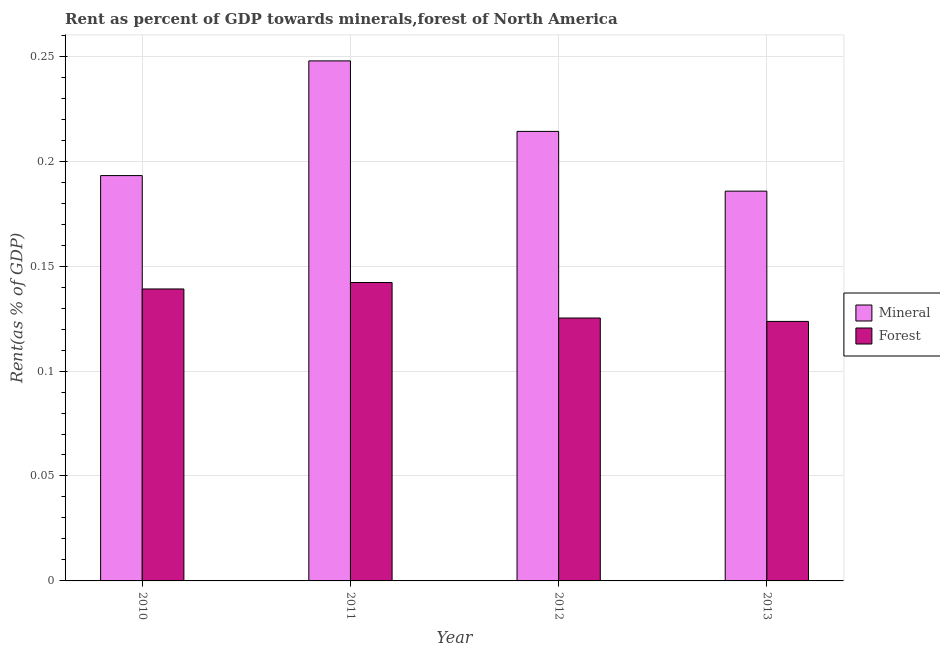How many different coloured bars are there?
Your answer should be compact. 2. How many bars are there on the 1st tick from the left?
Provide a succinct answer. 2. What is the label of the 2nd group of bars from the left?
Ensure brevity in your answer.  2011. In how many cases, is the number of bars for a given year not equal to the number of legend labels?
Offer a terse response. 0. What is the forest rent in 2012?
Your response must be concise. 0.13. Across all years, what is the maximum forest rent?
Keep it short and to the point. 0.14. Across all years, what is the minimum mineral rent?
Offer a very short reply. 0.19. In which year was the mineral rent maximum?
Offer a terse response. 2011. What is the total forest rent in the graph?
Offer a terse response. 0.53. What is the difference between the forest rent in 2011 and that in 2012?
Provide a short and direct response. 0.02. What is the difference between the forest rent in 2012 and the mineral rent in 2010?
Your response must be concise. -0.01. What is the average forest rent per year?
Offer a very short reply. 0.13. In the year 2010, what is the difference between the mineral rent and forest rent?
Your answer should be compact. 0. What is the ratio of the forest rent in 2010 to that in 2012?
Provide a succinct answer. 1.11. Is the difference between the mineral rent in 2010 and 2012 greater than the difference between the forest rent in 2010 and 2012?
Make the answer very short. No. What is the difference between the highest and the second highest mineral rent?
Your answer should be very brief. 0.03. What is the difference between the highest and the lowest mineral rent?
Offer a very short reply. 0.06. Is the sum of the forest rent in 2011 and 2013 greater than the maximum mineral rent across all years?
Provide a short and direct response. Yes. What does the 2nd bar from the left in 2010 represents?
Your answer should be very brief. Forest. What does the 1st bar from the right in 2013 represents?
Your answer should be compact. Forest. Are all the bars in the graph horizontal?
Ensure brevity in your answer.  No. What is the difference between two consecutive major ticks on the Y-axis?
Your answer should be very brief. 0.05. Are the values on the major ticks of Y-axis written in scientific E-notation?
Ensure brevity in your answer.  No. Where does the legend appear in the graph?
Provide a short and direct response. Center right. How many legend labels are there?
Offer a terse response. 2. What is the title of the graph?
Your answer should be compact. Rent as percent of GDP towards minerals,forest of North America. What is the label or title of the Y-axis?
Make the answer very short. Rent(as % of GDP). What is the Rent(as % of GDP) of Mineral in 2010?
Offer a terse response. 0.19. What is the Rent(as % of GDP) of Forest in 2010?
Provide a short and direct response. 0.14. What is the Rent(as % of GDP) in Mineral in 2011?
Your response must be concise. 0.25. What is the Rent(as % of GDP) of Forest in 2011?
Offer a terse response. 0.14. What is the Rent(as % of GDP) in Mineral in 2012?
Give a very brief answer. 0.21. What is the Rent(as % of GDP) in Forest in 2012?
Offer a terse response. 0.13. What is the Rent(as % of GDP) in Mineral in 2013?
Offer a very short reply. 0.19. What is the Rent(as % of GDP) of Forest in 2013?
Keep it short and to the point. 0.12. Across all years, what is the maximum Rent(as % of GDP) in Mineral?
Your response must be concise. 0.25. Across all years, what is the maximum Rent(as % of GDP) of Forest?
Offer a very short reply. 0.14. Across all years, what is the minimum Rent(as % of GDP) in Mineral?
Your answer should be compact. 0.19. Across all years, what is the minimum Rent(as % of GDP) in Forest?
Your answer should be very brief. 0.12. What is the total Rent(as % of GDP) of Mineral in the graph?
Offer a very short reply. 0.84. What is the total Rent(as % of GDP) in Forest in the graph?
Make the answer very short. 0.53. What is the difference between the Rent(as % of GDP) of Mineral in 2010 and that in 2011?
Your response must be concise. -0.05. What is the difference between the Rent(as % of GDP) of Forest in 2010 and that in 2011?
Your response must be concise. -0. What is the difference between the Rent(as % of GDP) in Mineral in 2010 and that in 2012?
Offer a terse response. -0.02. What is the difference between the Rent(as % of GDP) in Forest in 2010 and that in 2012?
Offer a terse response. 0.01. What is the difference between the Rent(as % of GDP) in Mineral in 2010 and that in 2013?
Provide a short and direct response. 0.01. What is the difference between the Rent(as % of GDP) in Forest in 2010 and that in 2013?
Make the answer very short. 0.02. What is the difference between the Rent(as % of GDP) of Mineral in 2011 and that in 2012?
Your answer should be very brief. 0.03. What is the difference between the Rent(as % of GDP) of Forest in 2011 and that in 2012?
Provide a succinct answer. 0.02. What is the difference between the Rent(as % of GDP) of Mineral in 2011 and that in 2013?
Provide a short and direct response. 0.06. What is the difference between the Rent(as % of GDP) of Forest in 2011 and that in 2013?
Offer a terse response. 0.02. What is the difference between the Rent(as % of GDP) of Mineral in 2012 and that in 2013?
Provide a short and direct response. 0.03. What is the difference between the Rent(as % of GDP) of Forest in 2012 and that in 2013?
Offer a very short reply. 0. What is the difference between the Rent(as % of GDP) in Mineral in 2010 and the Rent(as % of GDP) in Forest in 2011?
Provide a short and direct response. 0.05. What is the difference between the Rent(as % of GDP) of Mineral in 2010 and the Rent(as % of GDP) of Forest in 2012?
Your answer should be very brief. 0.07. What is the difference between the Rent(as % of GDP) in Mineral in 2010 and the Rent(as % of GDP) in Forest in 2013?
Give a very brief answer. 0.07. What is the difference between the Rent(as % of GDP) in Mineral in 2011 and the Rent(as % of GDP) in Forest in 2012?
Your answer should be compact. 0.12. What is the difference between the Rent(as % of GDP) in Mineral in 2011 and the Rent(as % of GDP) in Forest in 2013?
Offer a terse response. 0.12. What is the difference between the Rent(as % of GDP) in Mineral in 2012 and the Rent(as % of GDP) in Forest in 2013?
Give a very brief answer. 0.09. What is the average Rent(as % of GDP) in Mineral per year?
Give a very brief answer. 0.21. What is the average Rent(as % of GDP) of Forest per year?
Ensure brevity in your answer.  0.13. In the year 2010, what is the difference between the Rent(as % of GDP) in Mineral and Rent(as % of GDP) in Forest?
Offer a terse response. 0.05. In the year 2011, what is the difference between the Rent(as % of GDP) in Mineral and Rent(as % of GDP) in Forest?
Ensure brevity in your answer.  0.11. In the year 2012, what is the difference between the Rent(as % of GDP) in Mineral and Rent(as % of GDP) in Forest?
Give a very brief answer. 0.09. In the year 2013, what is the difference between the Rent(as % of GDP) in Mineral and Rent(as % of GDP) in Forest?
Your answer should be very brief. 0.06. What is the ratio of the Rent(as % of GDP) of Mineral in 2010 to that in 2011?
Provide a succinct answer. 0.78. What is the ratio of the Rent(as % of GDP) of Forest in 2010 to that in 2011?
Give a very brief answer. 0.98. What is the ratio of the Rent(as % of GDP) in Mineral in 2010 to that in 2012?
Give a very brief answer. 0.9. What is the ratio of the Rent(as % of GDP) in Forest in 2010 to that in 2012?
Your answer should be very brief. 1.11. What is the ratio of the Rent(as % of GDP) in Mineral in 2010 to that in 2013?
Keep it short and to the point. 1.04. What is the ratio of the Rent(as % of GDP) in Mineral in 2011 to that in 2012?
Ensure brevity in your answer.  1.16. What is the ratio of the Rent(as % of GDP) of Forest in 2011 to that in 2012?
Give a very brief answer. 1.14. What is the ratio of the Rent(as % of GDP) in Mineral in 2011 to that in 2013?
Ensure brevity in your answer.  1.33. What is the ratio of the Rent(as % of GDP) of Forest in 2011 to that in 2013?
Keep it short and to the point. 1.15. What is the ratio of the Rent(as % of GDP) of Mineral in 2012 to that in 2013?
Provide a short and direct response. 1.15. What is the ratio of the Rent(as % of GDP) in Forest in 2012 to that in 2013?
Keep it short and to the point. 1.01. What is the difference between the highest and the second highest Rent(as % of GDP) in Mineral?
Ensure brevity in your answer.  0.03. What is the difference between the highest and the second highest Rent(as % of GDP) in Forest?
Make the answer very short. 0. What is the difference between the highest and the lowest Rent(as % of GDP) in Mineral?
Your answer should be compact. 0.06. What is the difference between the highest and the lowest Rent(as % of GDP) of Forest?
Your answer should be compact. 0.02. 